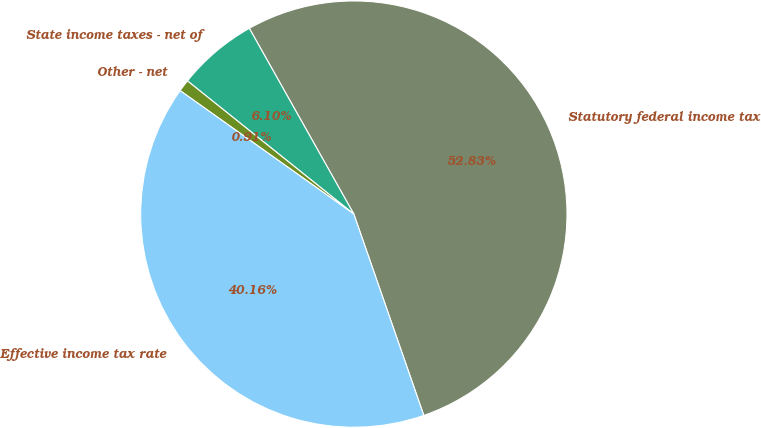<chart> <loc_0><loc_0><loc_500><loc_500><pie_chart><fcel>Statutory federal income tax<fcel>State income taxes - net of<fcel>Other - net<fcel>Effective income tax rate<nl><fcel>52.84%<fcel>6.1%<fcel>0.91%<fcel>40.16%<nl></chart> 